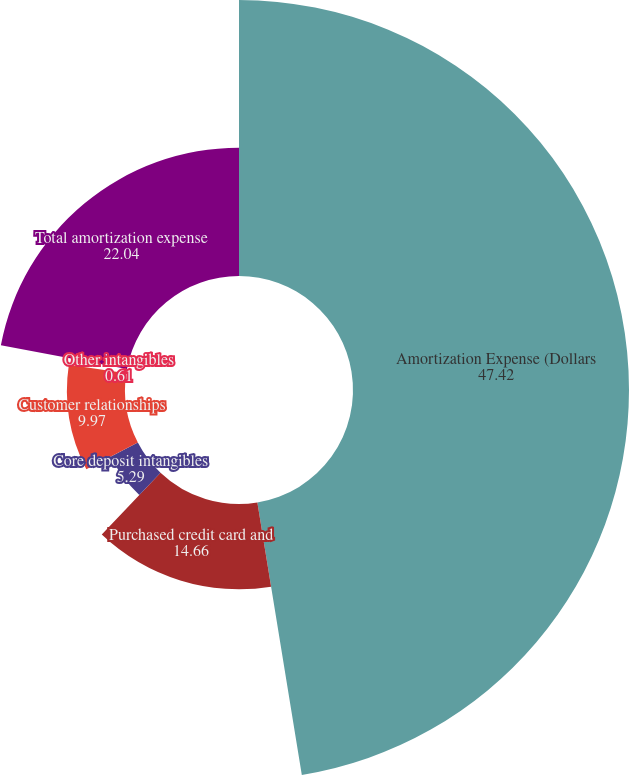<chart> <loc_0><loc_0><loc_500><loc_500><pie_chart><fcel>Amortization Expense (Dollars<fcel>Purchased credit card and<fcel>Core deposit intangibles<fcel>Customer relationships<fcel>Other intangibles<fcel>Total amortization expense<nl><fcel>47.42%<fcel>14.66%<fcel>5.29%<fcel>9.97%<fcel>0.61%<fcel>22.04%<nl></chart> 